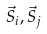Convert formula to latex. <formula><loc_0><loc_0><loc_500><loc_500>\vec { S } _ { i } , \vec { S } _ { j }</formula> 